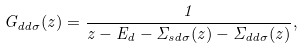<formula> <loc_0><loc_0><loc_500><loc_500>G _ { d d \sigma } ( z ) = \frac { 1 } { z - E _ { d } - \Sigma _ { s d \sigma } ( z ) - \Sigma _ { d d \sigma } ( z ) } ,</formula> 